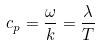<formula> <loc_0><loc_0><loc_500><loc_500>c _ { p } = \frac { \omega } { k } = \frac { \lambda } { T }</formula> 